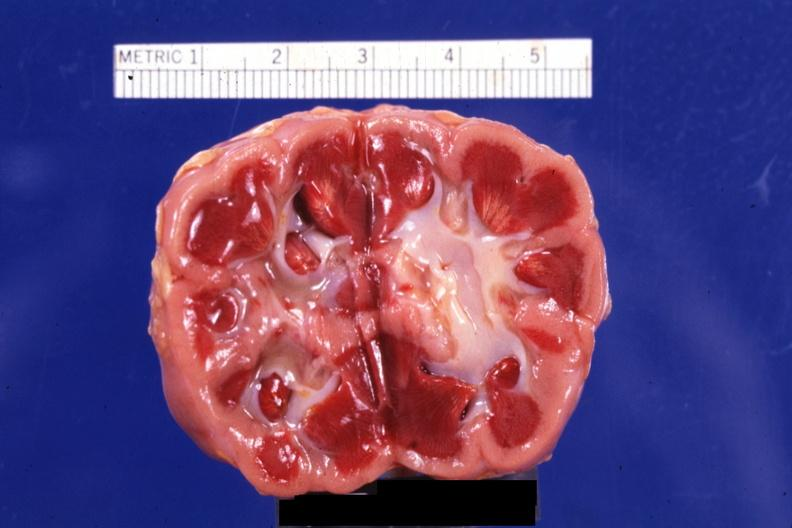where is this?
Answer the question using a single word or phrase. Urinary 